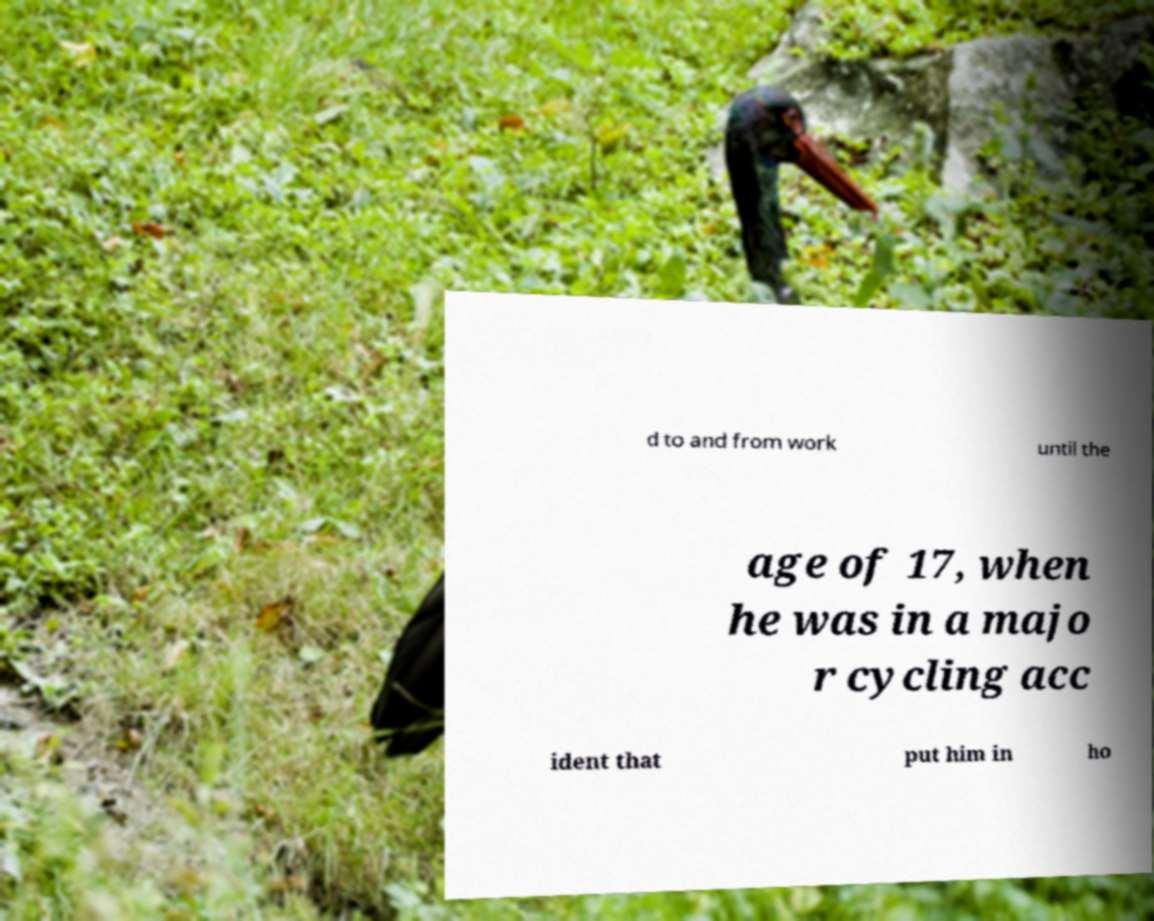Please read and relay the text visible in this image. What does it say? d to and from work until the age of 17, when he was in a majo r cycling acc ident that put him in ho 